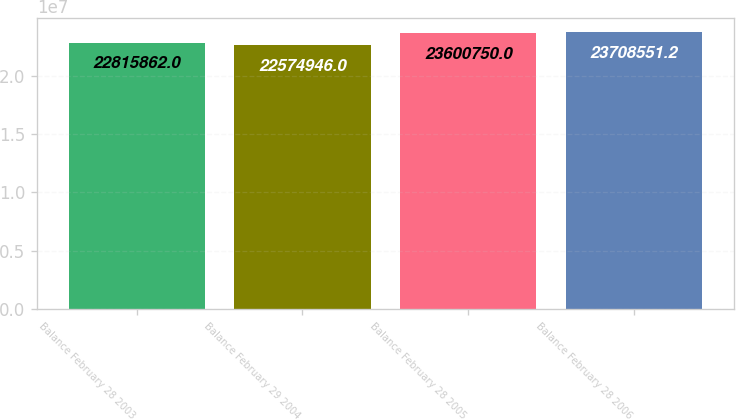<chart> <loc_0><loc_0><loc_500><loc_500><bar_chart><fcel>Balance February 28 2003<fcel>Balance February 29 2004<fcel>Balance February 28 2005<fcel>Balance February 28 2006<nl><fcel>2.28159e+07<fcel>2.25749e+07<fcel>2.36008e+07<fcel>2.37086e+07<nl></chart> 